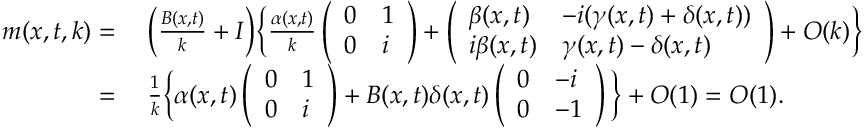<formula> <loc_0><loc_0><loc_500><loc_500>\begin{array} { r l } { m ( x , t , k ) = } & { \, \left ( \frac { B ( x , t ) } { k } + I \right ) \left \{ \frac { \alpha ( x , t ) } { k } \left ( \begin{array} { l l } { 0 } & { 1 } \\ { 0 } & { i } \end{array} \right ) + \left ( \begin{array} { l l } { \beta ( x , t ) } & { - i ( \gamma ( x , t ) + \delta ( x , t ) ) } \\ { i \beta ( x , t ) } & { \gamma ( x , t ) - \delta ( x , t ) } \end{array} \right ) + O ( k ) \right \} } \\ { = } & { \, \frac { 1 } { k } \left \{ \alpha ( x , t ) \left ( \begin{array} { l l } { 0 } & { 1 } \\ { 0 } & { i } \end{array} \right ) + B ( x , t ) \delta ( x , t ) \left ( \begin{array} { l l } { 0 } & { - i } \\ { 0 } & { - 1 } \end{array} \right ) \right \} + O ( 1 ) = O ( 1 ) . } \end{array}</formula> 